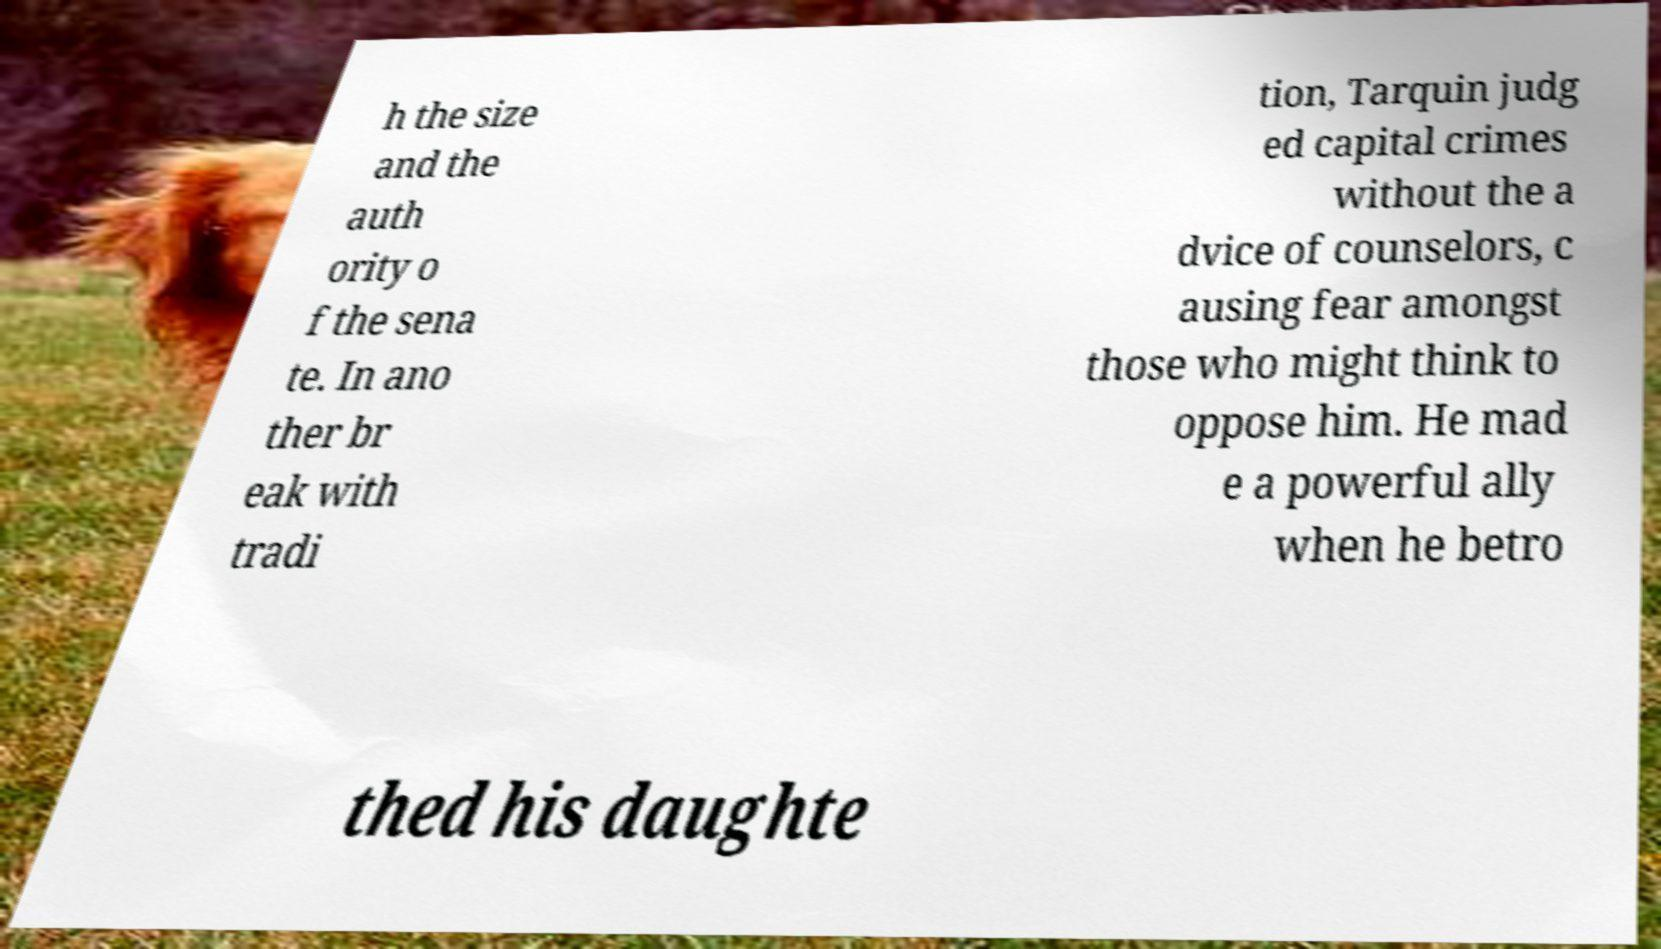Can you read and provide the text displayed in the image?This photo seems to have some interesting text. Can you extract and type it out for me? h the size and the auth ority o f the sena te. In ano ther br eak with tradi tion, Tarquin judg ed capital crimes without the a dvice of counselors, c ausing fear amongst those who might think to oppose him. He mad e a powerful ally when he betro thed his daughte 